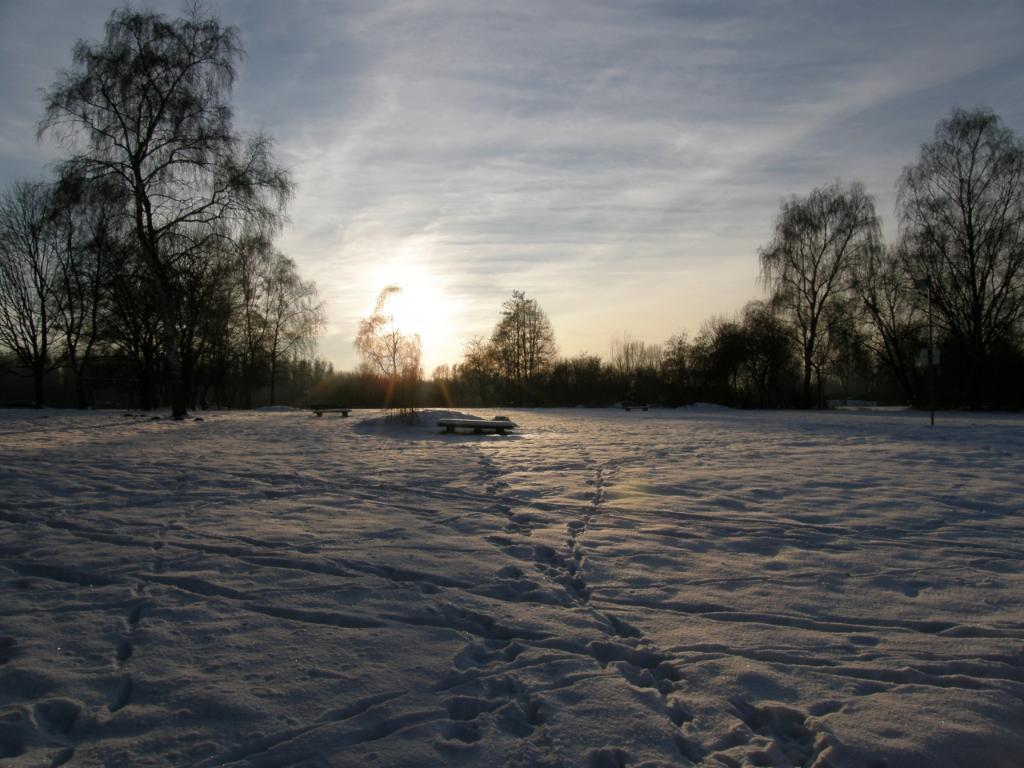What is the condition of the ground in the image? The ground is covered in snow. What can be seen in the background of the image? There are trees and the sky visible in the background of the image. What type of force is being applied to the trees in the image? There is no indication of any force being applied to the trees in the image; they are simply standing in the background. 